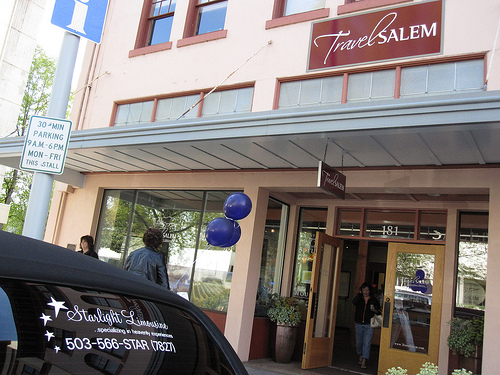<image>
Is the balloon on the wall? No. The balloon is not positioned on the wall. They may be near each other, but the balloon is not supported by or resting on top of the wall. 